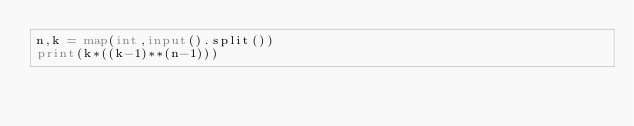Convert code to text. <code><loc_0><loc_0><loc_500><loc_500><_Python_>n,k = map(int,input().split())
print(k*((k-1)**(n-1)))</code> 